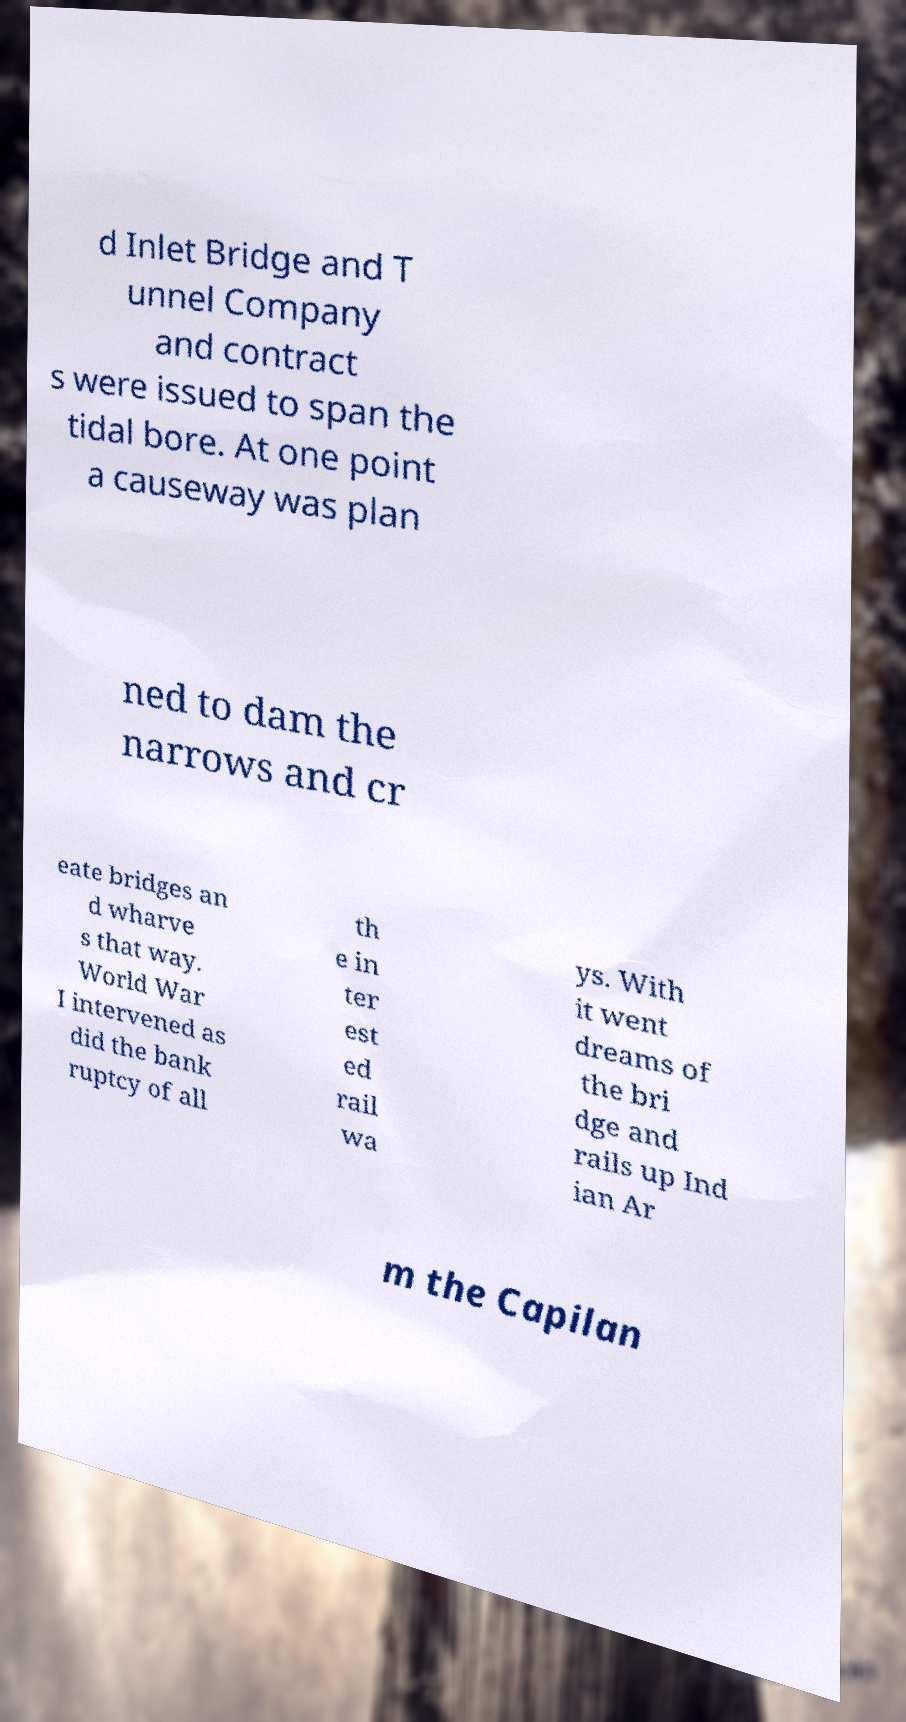Can you accurately transcribe the text from the provided image for me? d Inlet Bridge and T unnel Company and contract s were issued to span the tidal bore. At one point a causeway was plan ned to dam the narrows and cr eate bridges an d wharve s that way. World War I intervened as did the bank ruptcy of all th e in ter est ed rail wa ys. With it went dreams of the bri dge and rails up Ind ian Ar m the Capilan 